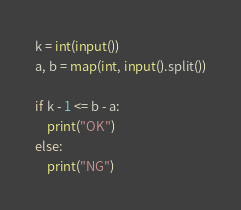Convert code to text. <code><loc_0><loc_0><loc_500><loc_500><_Python_>k = int(input())
a, b = map(int, input().split())

if k - 1 <= b - a:
    print("OK")
else:
    print("NG")</code> 